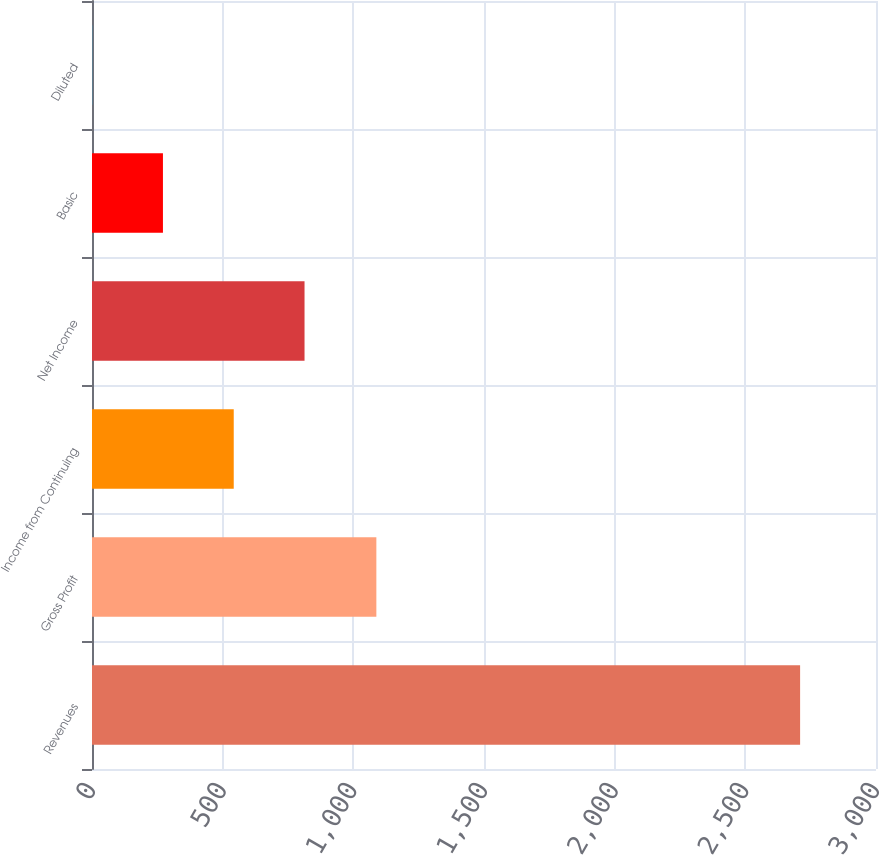Convert chart. <chart><loc_0><loc_0><loc_500><loc_500><bar_chart><fcel>Revenues<fcel>Gross Profit<fcel>Income from Continuing<fcel>Net Income<fcel>Basic<fcel>Diluted<nl><fcel>2709.6<fcel>1088.1<fcel>542.36<fcel>813.26<fcel>271.46<fcel>0.56<nl></chart> 